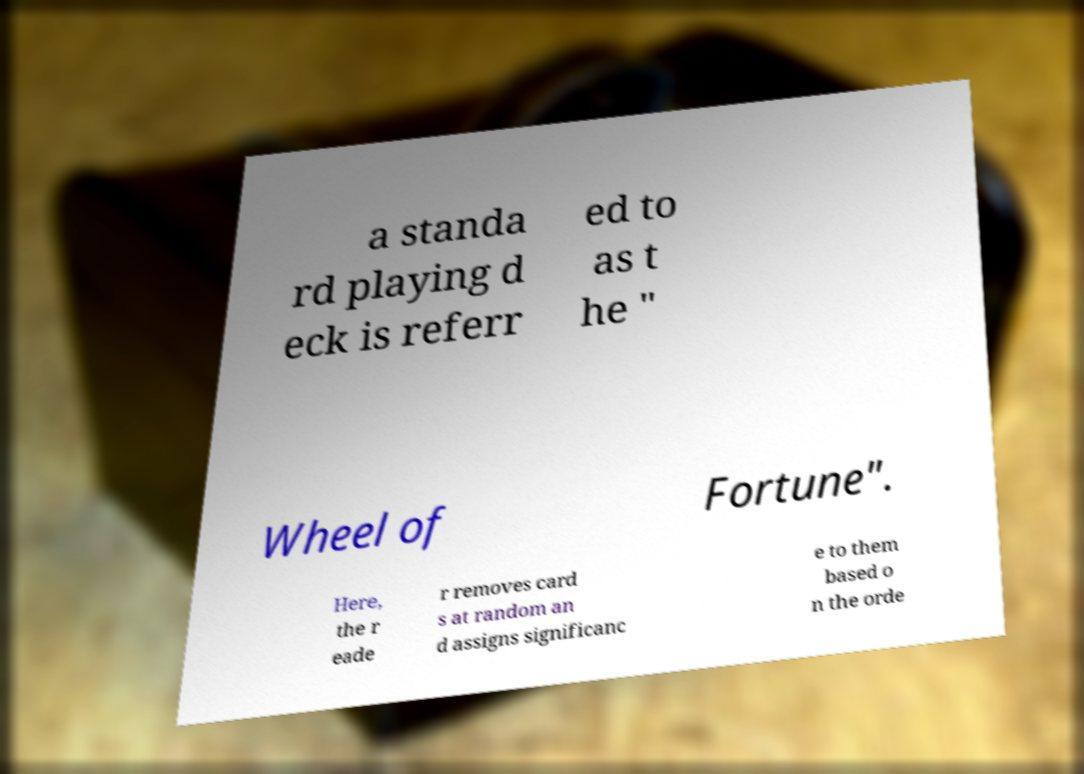Could you extract and type out the text from this image? a standa rd playing d eck is referr ed to as t he " Wheel of Fortune". Here, the r eade r removes card s at random an d assigns significanc e to them based o n the orde 